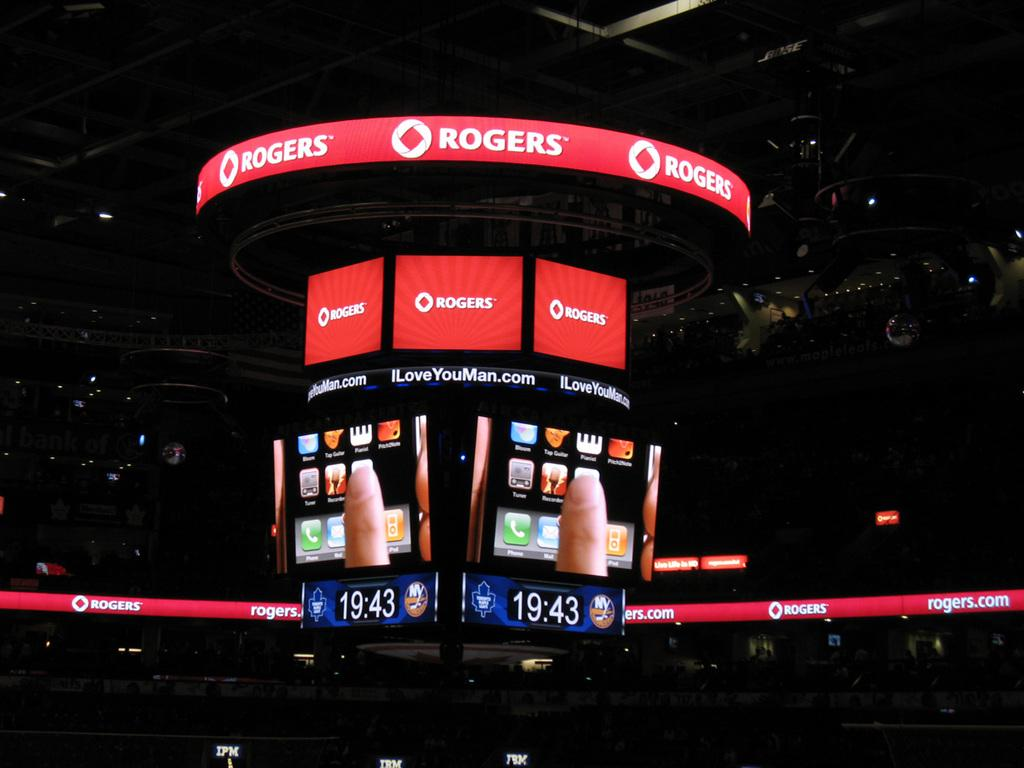What type of structure is visible in the image? There is a stadium in the image. What can be seen on the screens in the image? The screens are not described in the facts, so we cannot answer this question definitively. What type of lighting is present in the image? There are focus lights in the image. What other objects are present in the image? The facts mention that there are some objects in the image, but they are not described in detail. What type of cakes are being served in the afternoon at the stadium in the image? There is no mention of cakes or an afternoon event in the image, so we cannot answer this question definitively. 